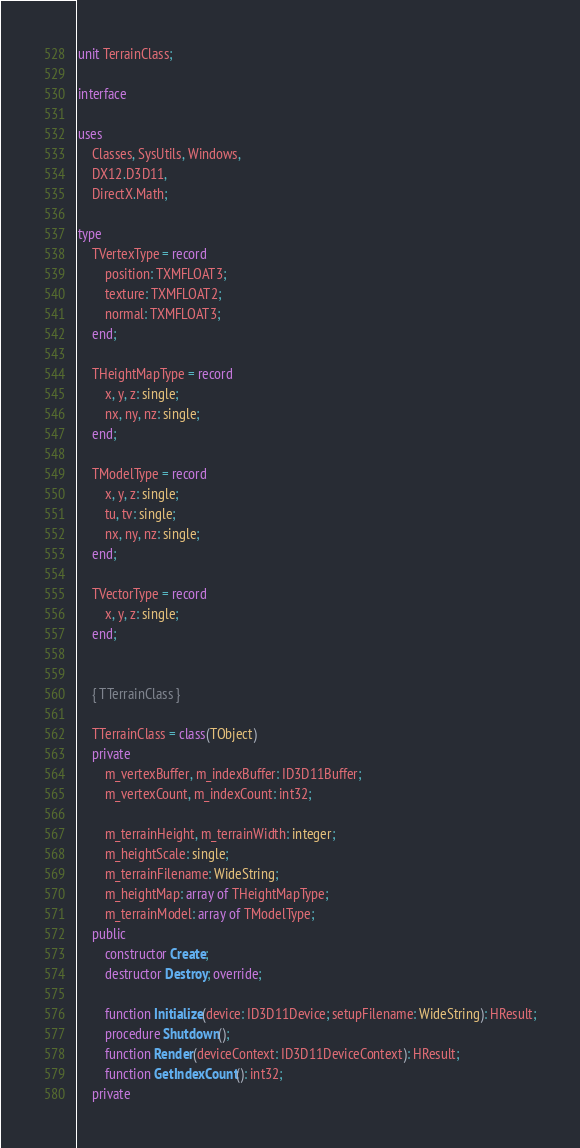<code> <loc_0><loc_0><loc_500><loc_500><_Pascal_>unit TerrainClass;

interface

uses
    Classes, SysUtils, Windows,
    DX12.D3D11,
    DirectX.Math;

type
    TVertexType = record
        position: TXMFLOAT3;
        texture: TXMFLOAT2;
        normal: TXMFLOAT3;
    end;

    THeightMapType = record
        x, y, z: single;
        nx, ny, nz: single;
    end;

    TModelType = record
        x, y, z: single;
        tu, tv: single;
        nx, ny, nz: single;
    end;

    TVectorType = record
        x, y, z: single;
    end;


    { TTerrainClass }

    TTerrainClass = class(TObject)
    private
        m_vertexBuffer, m_indexBuffer: ID3D11Buffer;
        m_vertexCount, m_indexCount: int32;

        m_terrainHeight, m_terrainWidth: integer;
        m_heightScale: single;
        m_terrainFilename: WideString;
        m_heightMap: array of THeightMapType;
        m_terrainModel: array of TModelType;
    public
        constructor Create;
        destructor Destroy; override;

        function Initialize(device: ID3D11Device; setupFilename: WideString): HResult;
        procedure Shutdown();
        function Render(deviceContext: ID3D11DeviceContext): HResult;
        function GetIndexCount(): int32;
    private</code> 